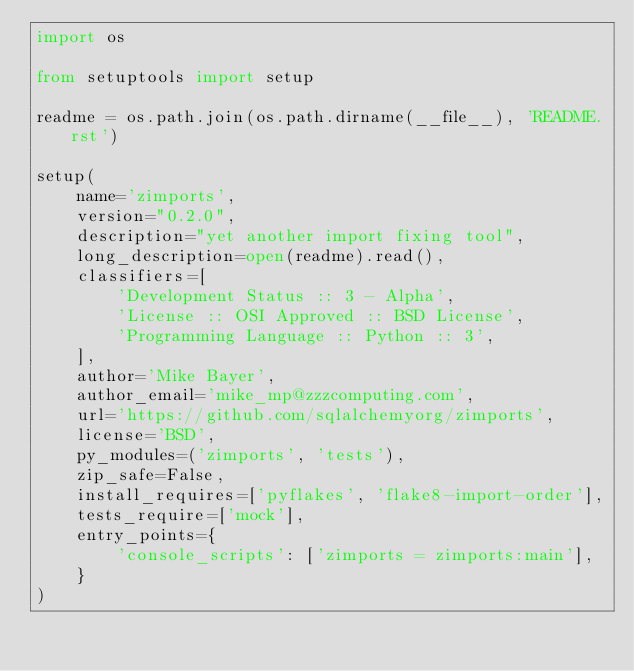<code> <loc_0><loc_0><loc_500><loc_500><_Python_>import os

from setuptools import setup

readme = os.path.join(os.path.dirname(__file__), 'README.rst')

setup(
    name='zimports',
    version="0.2.0",
    description="yet another import fixing tool",
    long_description=open(readme).read(),
    classifiers=[
        'Development Status :: 3 - Alpha',
        'License :: OSI Approved :: BSD License',
        'Programming Language :: Python :: 3',
    ],
    author='Mike Bayer',
    author_email='mike_mp@zzzcomputing.com',
    url='https://github.com/sqlalchemyorg/zimports',
    license='BSD',
    py_modules=('zimports', 'tests'),
    zip_safe=False,
    install_requires=['pyflakes', 'flake8-import-order'],
    tests_require=['mock'],
    entry_points={
        'console_scripts': ['zimports = zimports:main'],
    }
)
</code> 